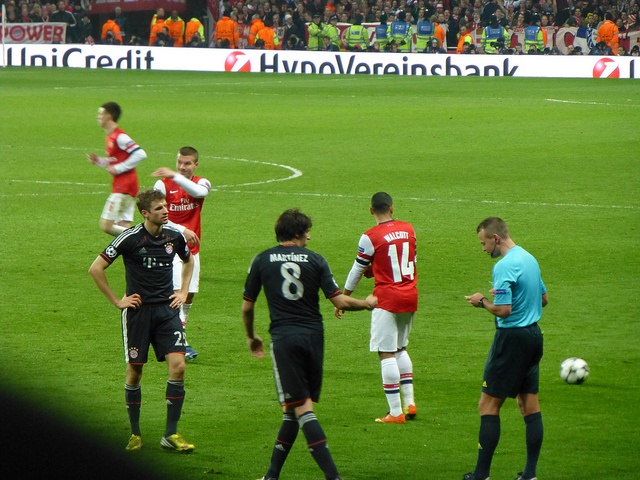Describe the objects in this image and their specific colors. I can see people in black, darkgreen, and gray tones, people in black, olive, and tan tones, people in black, darkgreen, lightblue, and teal tones, people in black, lightgray, brown, darkgray, and lightblue tones, and people in black, white, brown, tan, and maroon tones in this image. 